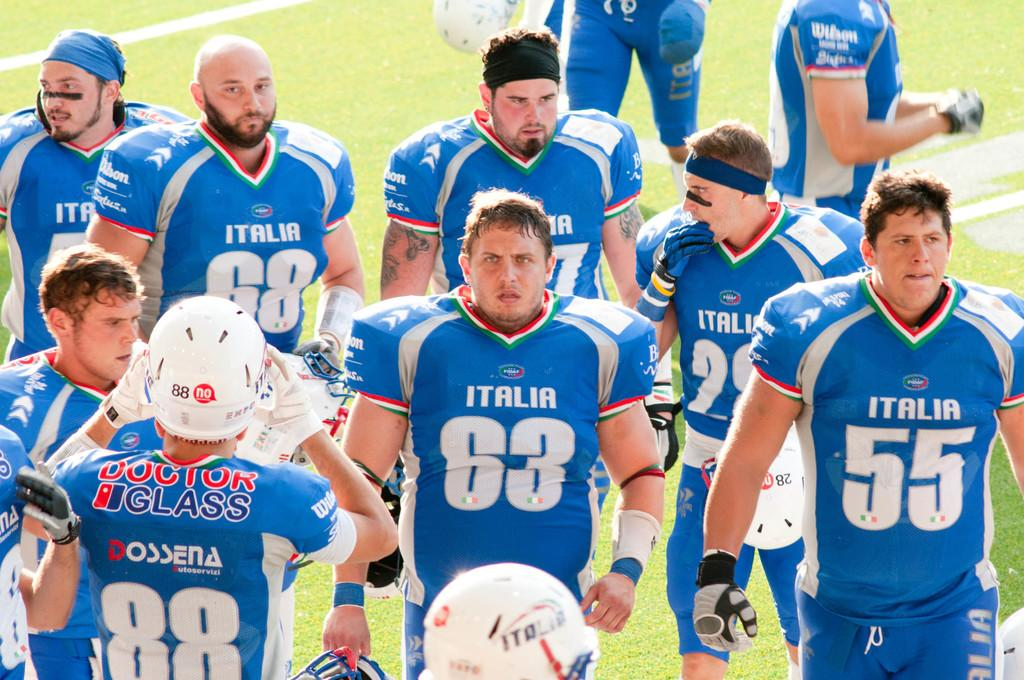<image>
Render a clear and concise summary of the photo. Player number 88 is adjusting his white helmet. 